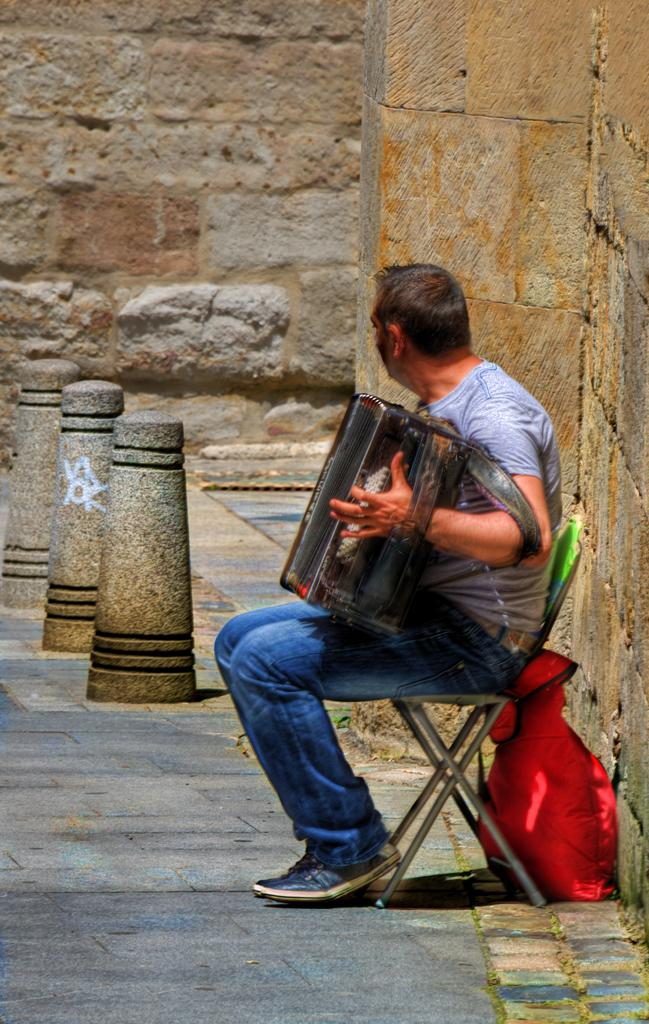Who is the main subject in the image? There is a man in the image. What is the man doing in the image? The man is playing a harmonium. Where is the man sitting in the image? The man is sitting on a chair. On which side of the image is the chair located? The chair is on the right side of the image. What type of beef is being served on the marble table in the image? There is no beef or marble table present in the image; it features a man playing a harmonium while sitting on a chair. 